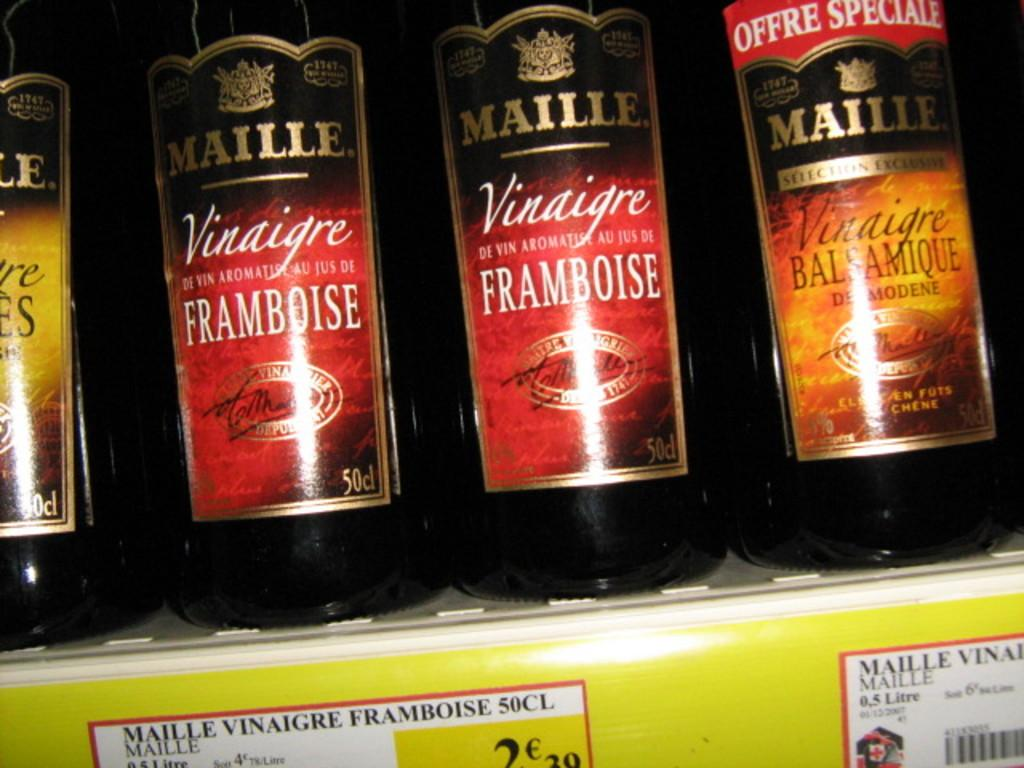<image>
Offer a succinct explanation of the picture presented. Three bottles of Maille Vinaigre sit on display on a shelf 